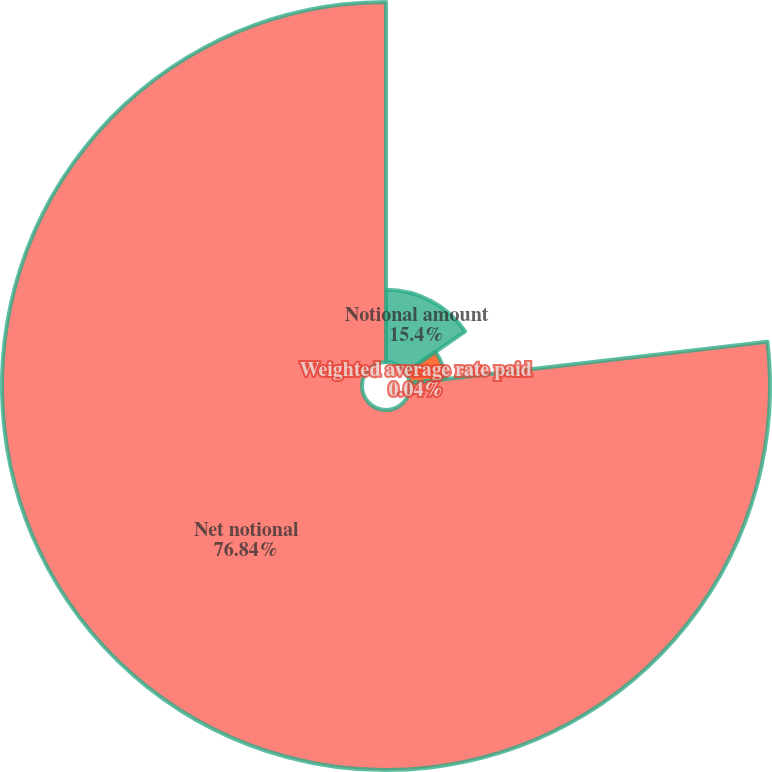<chart> <loc_0><loc_0><loc_500><loc_500><pie_chart><fcel>Notional amount<fcel>Weighted average rate received<fcel>Weighted average rate paid<fcel>Net notional<nl><fcel>15.4%<fcel>7.72%<fcel>0.04%<fcel>76.85%<nl></chart> 